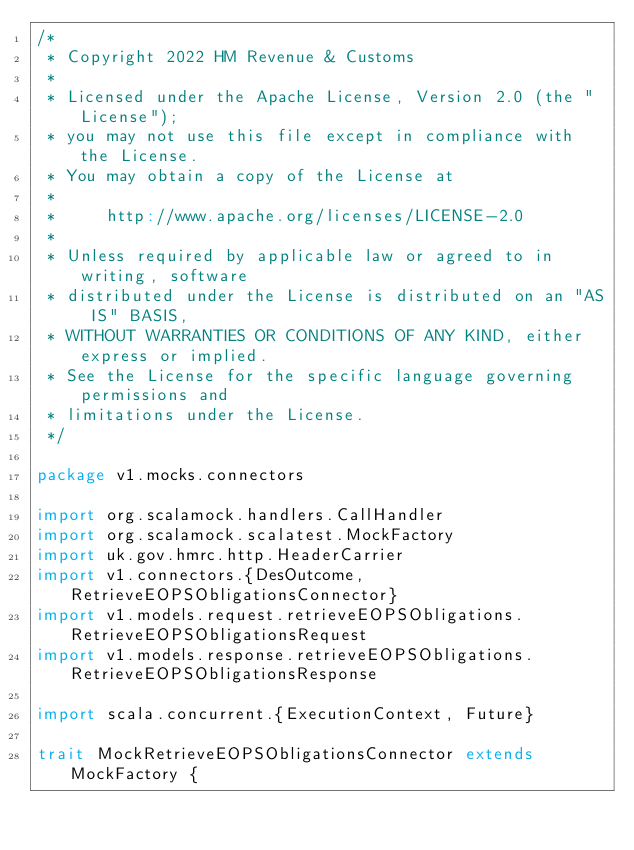Convert code to text. <code><loc_0><loc_0><loc_500><loc_500><_Scala_>/*
 * Copyright 2022 HM Revenue & Customs
 *
 * Licensed under the Apache License, Version 2.0 (the "License");
 * you may not use this file except in compliance with the License.
 * You may obtain a copy of the License at
 *
 *     http://www.apache.org/licenses/LICENSE-2.0
 *
 * Unless required by applicable law or agreed to in writing, software
 * distributed under the License is distributed on an "AS IS" BASIS,
 * WITHOUT WARRANTIES OR CONDITIONS OF ANY KIND, either express or implied.
 * See the License for the specific language governing permissions and
 * limitations under the License.
 */

package v1.mocks.connectors

import org.scalamock.handlers.CallHandler
import org.scalamock.scalatest.MockFactory
import uk.gov.hmrc.http.HeaderCarrier
import v1.connectors.{DesOutcome, RetrieveEOPSObligationsConnector}
import v1.models.request.retrieveEOPSObligations.RetrieveEOPSObligationsRequest
import v1.models.response.retrieveEOPSObligations.RetrieveEOPSObligationsResponse

import scala.concurrent.{ExecutionContext, Future}

trait MockRetrieveEOPSObligationsConnector extends MockFactory {</code> 